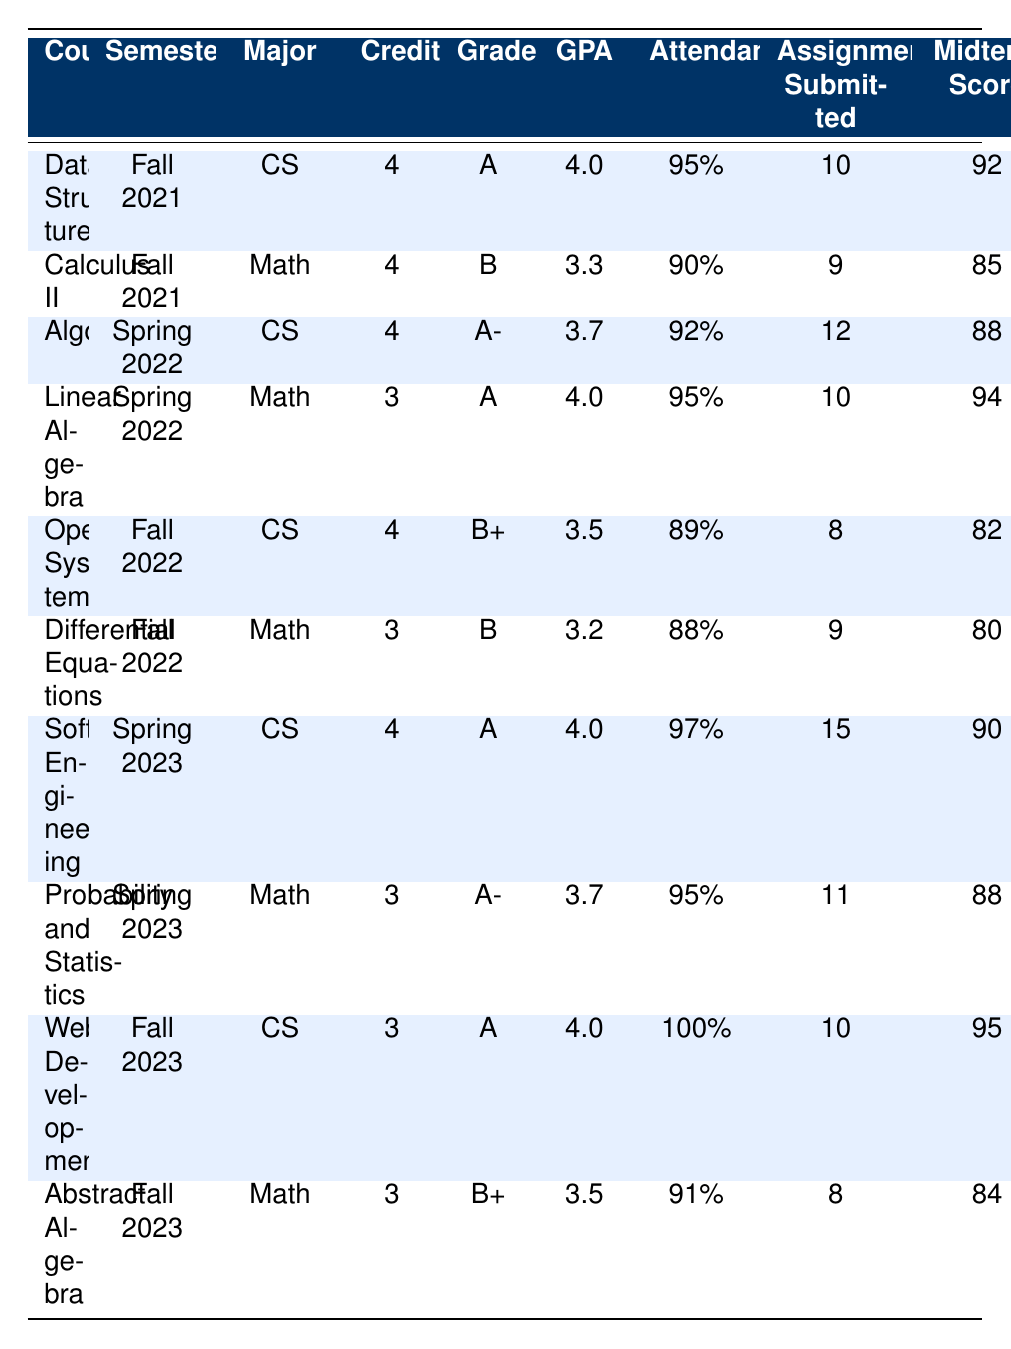What grade did you receive in Algorithms? Referring to the table, under the course "Algorithms" listed for Semester Spring 2022, the grade is "A-."
Answer: A- What was the midterm score for Abstract Algebra? The table shows that for the course "Abstract Algebra," taken in Fall 2023, the midterm score is 84.
Answer: 84 Which Computer Science course had the highest attendance? The courses in Computer Science with their attendance are Data Structures (95%), Algorithms (92%), Operating Systems (89%), Software Engineering (97%), and Web Development (100%). Web Development has the highest attendance at 100%.
Answer: 100% What is the average GPA for Mathematics courses over the semesters? The GPAs for Mathematics courses are 3.3 (Calculus II), 4.0 (Linear Algebra), 3.2 (Differential Equations), 3.7 (Probability and Statistics), and 3.5 (Abstract Algebra). Summing them gives 3.3 + 4.0 + 3.2 + 3.7 + 3.5 = 17.7. There are 5 courses, so the average GPA is 17.7 / 5 = 3.54.
Answer: 3.54 Did you maintain at least 90% attendance in all your courses? Checking the attendance figures for each course in the table: Data Structures (95%), Calculus II (90%), Algorithms (92%), Linear Algebra (95%), Operating Systems (89%), Differential Equations (88%), Software Engineering (97%), Probability and Statistics (95%), Web Development (100%), and Abstract Algebra (91%). Operating Systems (89%) and Differential Equations (88%) are below 90%, so the answer is no.
Answer: No What is the difference in final scores between Software Engineering and Operating Systems? For Software Engineering, the final score is 93, and for Operating Systems, the final score is 85. The difference is calculated as 93 - 85 = 8.
Answer: 8 Which semester had the most assignments submitted for Computer Science courses? The assignments submitted in Computer Science courses are: 10 (Data Structures), 12 (Algorithms), 8 (Operating Systems), 15 (Software Engineering), and 10 (Web Development). The highest number is 15 for Software Engineering in Spring 2023.
Answer: Spring 2023 Did your GPA improve from Fall 2021 to Fall 2023 in Computer Science? Checking the GPAs from the table: Fall 2021 (Data Structures) - 4.0, Fall 2022 (Operating Systems) - 3.5, Fall 2023 (Web Development) - 4.0. The GPA improved from 4.0 to a low of 3.5, but returned to 4.0, indicating it did not consistently improve.
Answer: No What was your total credits for the semesters? The total credits for each course are: Data Structures (4), Calculus II (4), Algorithms (4), Linear Algebra (3), Operating Systems (4), Differential Equations (3), Software Engineering (4), Probability and Statistics (3), Web Development (3), and Abstract Algebra (3). Summing these gives 4 + 4 + 4 + 3 + 4 + 3 + 4 + 3 + 3 + 3 = 38.
Answer: 38 